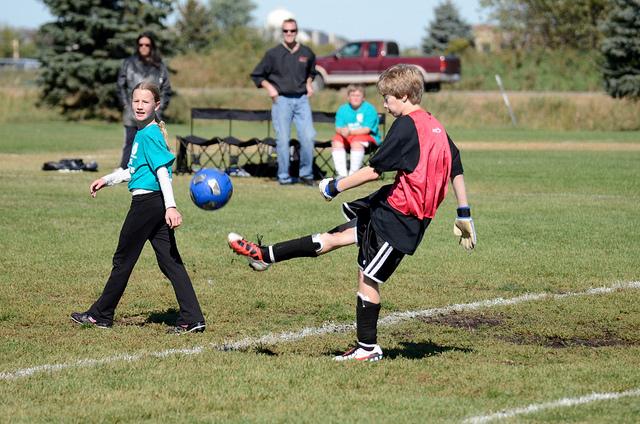What color are the boy's socks?
Answer briefly. Black. Does the girl look annoyed?
Give a very brief answer. Yes. What game is the boy playing?
Give a very brief answer. Soccer. What foot is the child primarily standing on?
Write a very short answer. Left. What color is the ball?
Concise answer only. Blue. 